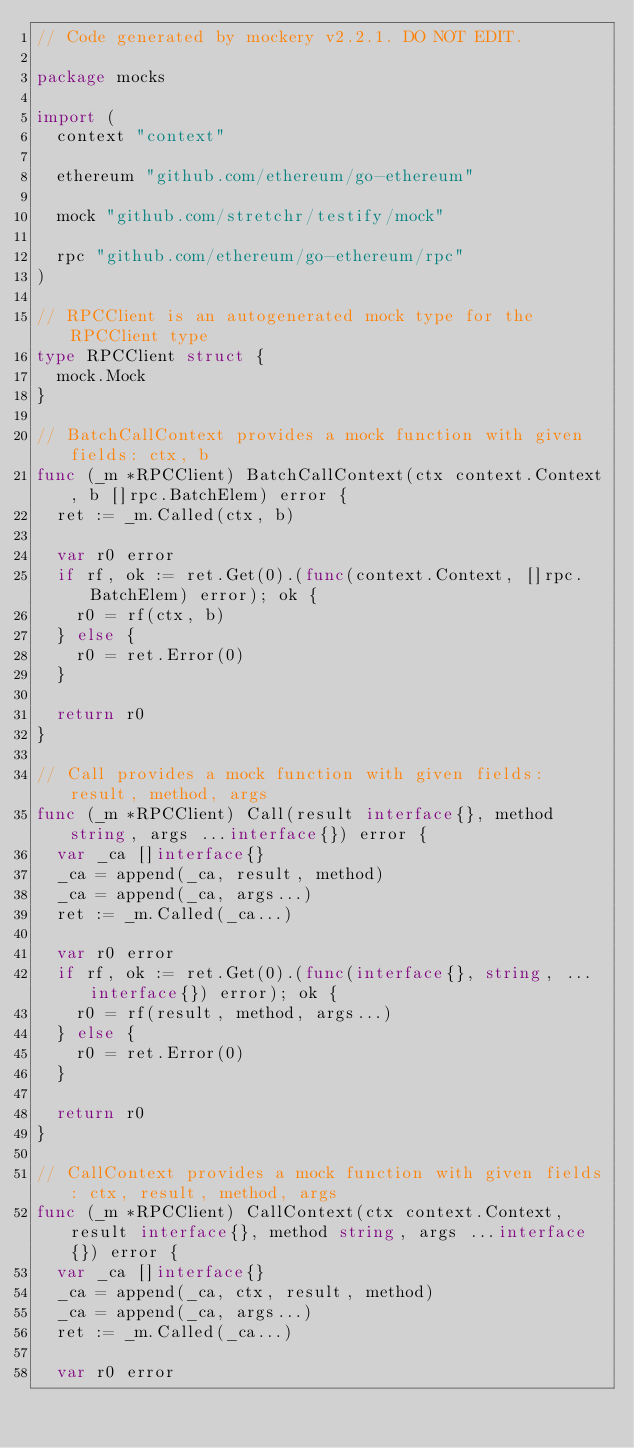<code> <loc_0><loc_0><loc_500><loc_500><_Go_>// Code generated by mockery v2.2.1. DO NOT EDIT.

package mocks

import (
	context "context"

	ethereum "github.com/ethereum/go-ethereum"

	mock "github.com/stretchr/testify/mock"

	rpc "github.com/ethereum/go-ethereum/rpc"
)

// RPCClient is an autogenerated mock type for the RPCClient type
type RPCClient struct {
	mock.Mock
}

// BatchCallContext provides a mock function with given fields: ctx, b
func (_m *RPCClient) BatchCallContext(ctx context.Context, b []rpc.BatchElem) error {
	ret := _m.Called(ctx, b)

	var r0 error
	if rf, ok := ret.Get(0).(func(context.Context, []rpc.BatchElem) error); ok {
		r0 = rf(ctx, b)
	} else {
		r0 = ret.Error(0)
	}

	return r0
}

// Call provides a mock function with given fields: result, method, args
func (_m *RPCClient) Call(result interface{}, method string, args ...interface{}) error {
	var _ca []interface{}
	_ca = append(_ca, result, method)
	_ca = append(_ca, args...)
	ret := _m.Called(_ca...)

	var r0 error
	if rf, ok := ret.Get(0).(func(interface{}, string, ...interface{}) error); ok {
		r0 = rf(result, method, args...)
	} else {
		r0 = ret.Error(0)
	}

	return r0
}

// CallContext provides a mock function with given fields: ctx, result, method, args
func (_m *RPCClient) CallContext(ctx context.Context, result interface{}, method string, args ...interface{}) error {
	var _ca []interface{}
	_ca = append(_ca, ctx, result, method)
	_ca = append(_ca, args...)
	ret := _m.Called(_ca...)

	var r0 error</code> 